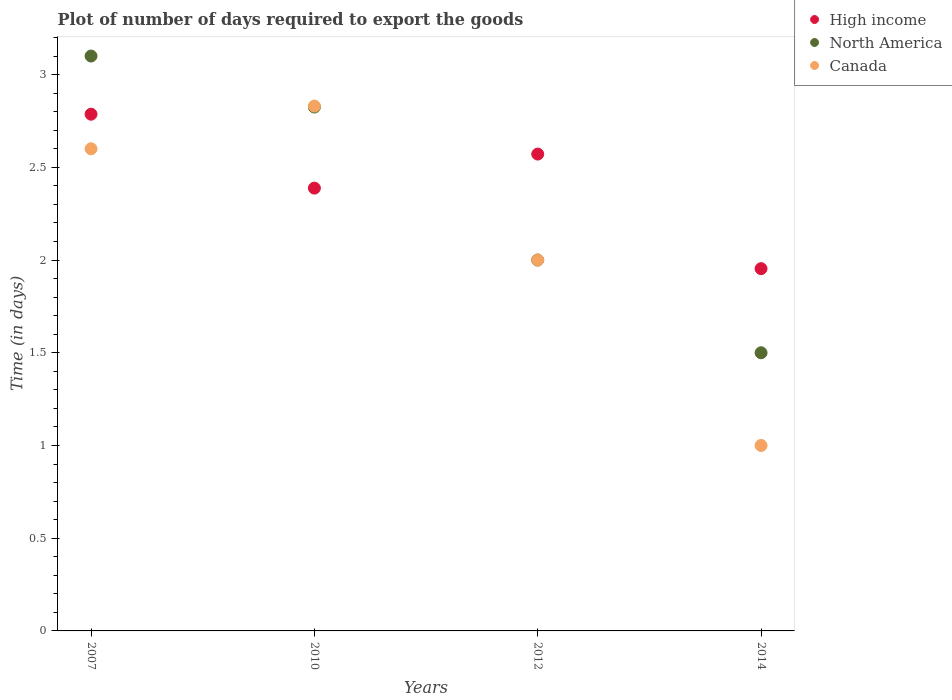Is the number of dotlines equal to the number of legend labels?
Make the answer very short. Yes. What is the time required to export goods in North America in 2014?
Provide a short and direct response. 1.5. Across all years, what is the maximum time required to export goods in North America?
Ensure brevity in your answer.  3.1. Across all years, what is the minimum time required to export goods in High income?
Your response must be concise. 1.95. In which year was the time required to export goods in North America minimum?
Your answer should be compact. 2014. What is the total time required to export goods in North America in the graph?
Provide a short and direct response. 9.43. What is the difference between the time required to export goods in Canada in 2014 and the time required to export goods in High income in 2012?
Provide a succinct answer. -1.57. What is the average time required to export goods in North America per year?
Provide a short and direct response. 2.36. What is the ratio of the time required to export goods in North America in 2007 to that in 2010?
Make the answer very short. 1.1. Is the time required to export goods in North America in 2010 less than that in 2014?
Your response must be concise. No. What is the difference between the highest and the second highest time required to export goods in Canada?
Provide a succinct answer. 0.23. What is the difference between the highest and the lowest time required to export goods in High income?
Provide a succinct answer. 0.83. Is the sum of the time required to export goods in Canada in 2010 and 2012 greater than the maximum time required to export goods in High income across all years?
Offer a very short reply. Yes. Is the time required to export goods in North America strictly greater than the time required to export goods in High income over the years?
Your answer should be very brief. No. Is the time required to export goods in Canada strictly less than the time required to export goods in North America over the years?
Offer a terse response. No. What is the difference between two consecutive major ticks on the Y-axis?
Provide a short and direct response. 0.5. Does the graph contain grids?
Your response must be concise. No. Where does the legend appear in the graph?
Offer a terse response. Top right. How many legend labels are there?
Your answer should be very brief. 3. What is the title of the graph?
Keep it short and to the point. Plot of number of days required to export the goods. Does "OECD members" appear as one of the legend labels in the graph?
Keep it short and to the point. No. What is the label or title of the Y-axis?
Ensure brevity in your answer.  Time (in days). What is the Time (in days) of High income in 2007?
Provide a short and direct response. 2.79. What is the Time (in days) of North America in 2007?
Make the answer very short. 3.1. What is the Time (in days) of High income in 2010?
Offer a terse response. 2.39. What is the Time (in days) in North America in 2010?
Provide a short and direct response. 2.83. What is the Time (in days) of Canada in 2010?
Offer a very short reply. 2.83. What is the Time (in days) of High income in 2012?
Offer a terse response. 2.57. What is the Time (in days) in Canada in 2012?
Offer a very short reply. 2. What is the Time (in days) of High income in 2014?
Your answer should be very brief. 1.95. What is the Time (in days) of Canada in 2014?
Ensure brevity in your answer.  1. Across all years, what is the maximum Time (in days) in High income?
Offer a terse response. 2.79. Across all years, what is the maximum Time (in days) in North America?
Your answer should be compact. 3.1. Across all years, what is the maximum Time (in days) of Canada?
Give a very brief answer. 2.83. Across all years, what is the minimum Time (in days) of High income?
Keep it short and to the point. 1.95. Across all years, what is the minimum Time (in days) of North America?
Offer a very short reply. 1.5. Across all years, what is the minimum Time (in days) in Canada?
Offer a terse response. 1. What is the total Time (in days) in High income in the graph?
Offer a very short reply. 9.7. What is the total Time (in days) in North America in the graph?
Your response must be concise. 9.43. What is the total Time (in days) in Canada in the graph?
Offer a very short reply. 8.43. What is the difference between the Time (in days) in High income in 2007 and that in 2010?
Provide a succinct answer. 0.4. What is the difference between the Time (in days) of North America in 2007 and that in 2010?
Offer a terse response. 0.28. What is the difference between the Time (in days) of Canada in 2007 and that in 2010?
Your answer should be compact. -0.23. What is the difference between the Time (in days) in High income in 2007 and that in 2012?
Your answer should be compact. 0.21. What is the difference between the Time (in days) in North America in 2007 and that in 2012?
Ensure brevity in your answer.  1.1. What is the difference between the Time (in days) of Canada in 2007 and that in 2012?
Offer a terse response. 0.6. What is the difference between the Time (in days) of High income in 2007 and that in 2014?
Provide a short and direct response. 0.83. What is the difference between the Time (in days) of Canada in 2007 and that in 2014?
Offer a terse response. 1.6. What is the difference between the Time (in days) in High income in 2010 and that in 2012?
Make the answer very short. -0.18. What is the difference between the Time (in days) in North America in 2010 and that in 2012?
Give a very brief answer. 0.82. What is the difference between the Time (in days) in Canada in 2010 and that in 2012?
Give a very brief answer. 0.83. What is the difference between the Time (in days) of High income in 2010 and that in 2014?
Provide a short and direct response. 0.43. What is the difference between the Time (in days) in North America in 2010 and that in 2014?
Make the answer very short. 1.32. What is the difference between the Time (in days) in Canada in 2010 and that in 2014?
Provide a short and direct response. 1.83. What is the difference between the Time (in days) in High income in 2012 and that in 2014?
Provide a succinct answer. 0.62. What is the difference between the Time (in days) of High income in 2007 and the Time (in days) of North America in 2010?
Offer a terse response. -0.04. What is the difference between the Time (in days) of High income in 2007 and the Time (in days) of Canada in 2010?
Make the answer very short. -0.04. What is the difference between the Time (in days) of North America in 2007 and the Time (in days) of Canada in 2010?
Make the answer very short. 0.27. What is the difference between the Time (in days) of High income in 2007 and the Time (in days) of North America in 2012?
Ensure brevity in your answer.  0.79. What is the difference between the Time (in days) of High income in 2007 and the Time (in days) of Canada in 2012?
Offer a very short reply. 0.79. What is the difference between the Time (in days) in High income in 2007 and the Time (in days) in North America in 2014?
Your answer should be very brief. 1.29. What is the difference between the Time (in days) of High income in 2007 and the Time (in days) of Canada in 2014?
Offer a very short reply. 1.79. What is the difference between the Time (in days) of High income in 2010 and the Time (in days) of North America in 2012?
Provide a succinct answer. 0.39. What is the difference between the Time (in days) in High income in 2010 and the Time (in days) in Canada in 2012?
Offer a very short reply. 0.39. What is the difference between the Time (in days) of North America in 2010 and the Time (in days) of Canada in 2012?
Provide a short and direct response. 0.82. What is the difference between the Time (in days) in High income in 2010 and the Time (in days) in North America in 2014?
Keep it short and to the point. 0.89. What is the difference between the Time (in days) of High income in 2010 and the Time (in days) of Canada in 2014?
Your response must be concise. 1.39. What is the difference between the Time (in days) in North America in 2010 and the Time (in days) in Canada in 2014?
Provide a succinct answer. 1.82. What is the difference between the Time (in days) of High income in 2012 and the Time (in days) of North America in 2014?
Your answer should be very brief. 1.07. What is the difference between the Time (in days) in High income in 2012 and the Time (in days) in Canada in 2014?
Your answer should be very brief. 1.57. What is the average Time (in days) in High income per year?
Your answer should be very brief. 2.42. What is the average Time (in days) of North America per year?
Make the answer very short. 2.36. What is the average Time (in days) of Canada per year?
Offer a terse response. 2.11. In the year 2007, what is the difference between the Time (in days) in High income and Time (in days) in North America?
Your answer should be very brief. -0.31. In the year 2007, what is the difference between the Time (in days) in High income and Time (in days) in Canada?
Your answer should be compact. 0.19. In the year 2007, what is the difference between the Time (in days) in North America and Time (in days) in Canada?
Provide a short and direct response. 0.5. In the year 2010, what is the difference between the Time (in days) of High income and Time (in days) of North America?
Keep it short and to the point. -0.44. In the year 2010, what is the difference between the Time (in days) in High income and Time (in days) in Canada?
Provide a succinct answer. -0.44. In the year 2010, what is the difference between the Time (in days) of North America and Time (in days) of Canada?
Your answer should be compact. -0.01. In the year 2012, what is the difference between the Time (in days) in High income and Time (in days) in Canada?
Your response must be concise. 0.57. In the year 2012, what is the difference between the Time (in days) in North America and Time (in days) in Canada?
Make the answer very short. 0. In the year 2014, what is the difference between the Time (in days) in High income and Time (in days) in North America?
Provide a succinct answer. 0.45. In the year 2014, what is the difference between the Time (in days) of High income and Time (in days) of Canada?
Provide a short and direct response. 0.95. What is the ratio of the Time (in days) of High income in 2007 to that in 2010?
Give a very brief answer. 1.17. What is the ratio of the Time (in days) of North America in 2007 to that in 2010?
Your answer should be compact. 1.1. What is the ratio of the Time (in days) in Canada in 2007 to that in 2010?
Your response must be concise. 0.92. What is the ratio of the Time (in days) in High income in 2007 to that in 2012?
Your answer should be very brief. 1.08. What is the ratio of the Time (in days) in North America in 2007 to that in 2012?
Ensure brevity in your answer.  1.55. What is the ratio of the Time (in days) of High income in 2007 to that in 2014?
Your answer should be compact. 1.43. What is the ratio of the Time (in days) of North America in 2007 to that in 2014?
Make the answer very short. 2.07. What is the ratio of the Time (in days) of Canada in 2007 to that in 2014?
Offer a very short reply. 2.6. What is the ratio of the Time (in days) of North America in 2010 to that in 2012?
Ensure brevity in your answer.  1.41. What is the ratio of the Time (in days) in Canada in 2010 to that in 2012?
Provide a succinct answer. 1.42. What is the ratio of the Time (in days) of High income in 2010 to that in 2014?
Provide a succinct answer. 1.22. What is the ratio of the Time (in days) in North America in 2010 to that in 2014?
Provide a succinct answer. 1.88. What is the ratio of the Time (in days) of Canada in 2010 to that in 2014?
Make the answer very short. 2.83. What is the ratio of the Time (in days) of High income in 2012 to that in 2014?
Provide a succinct answer. 1.32. What is the ratio of the Time (in days) in Canada in 2012 to that in 2014?
Your answer should be very brief. 2. What is the difference between the highest and the second highest Time (in days) in High income?
Ensure brevity in your answer.  0.21. What is the difference between the highest and the second highest Time (in days) of North America?
Your answer should be very brief. 0.28. What is the difference between the highest and the second highest Time (in days) of Canada?
Provide a succinct answer. 0.23. What is the difference between the highest and the lowest Time (in days) in High income?
Give a very brief answer. 0.83. What is the difference between the highest and the lowest Time (in days) in North America?
Offer a terse response. 1.6. What is the difference between the highest and the lowest Time (in days) in Canada?
Provide a short and direct response. 1.83. 